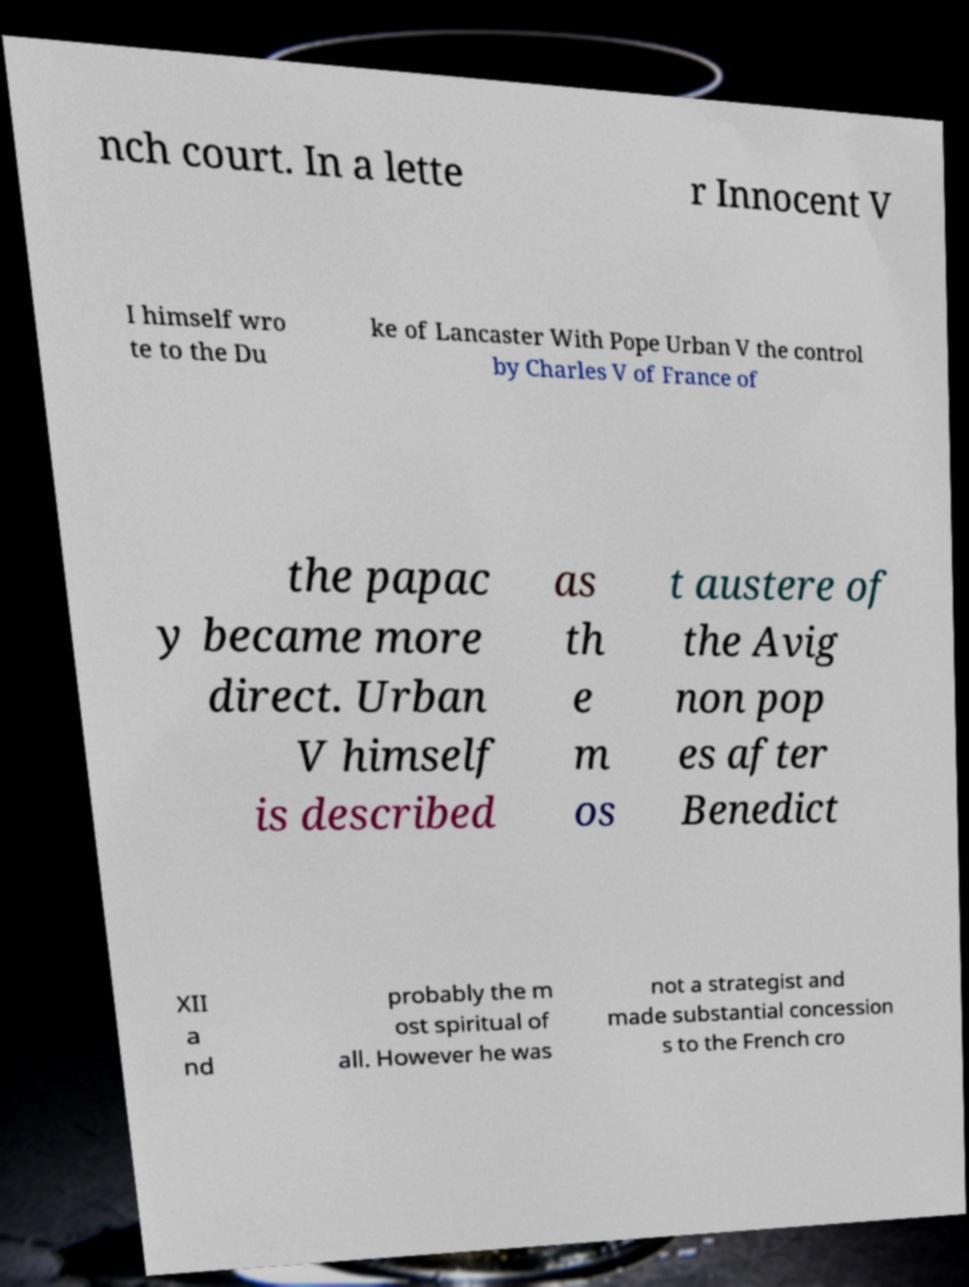What messages or text are displayed in this image? I need them in a readable, typed format. nch court. In a lette r Innocent V I himself wro te to the Du ke of Lancaster With Pope Urban V the control by Charles V of France of the papac y became more direct. Urban V himself is described as th e m os t austere of the Avig non pop es after Benedict XII a nd probably the m ost spiritual of all. However he was not a strategist and made substantial concession s to the French cro 